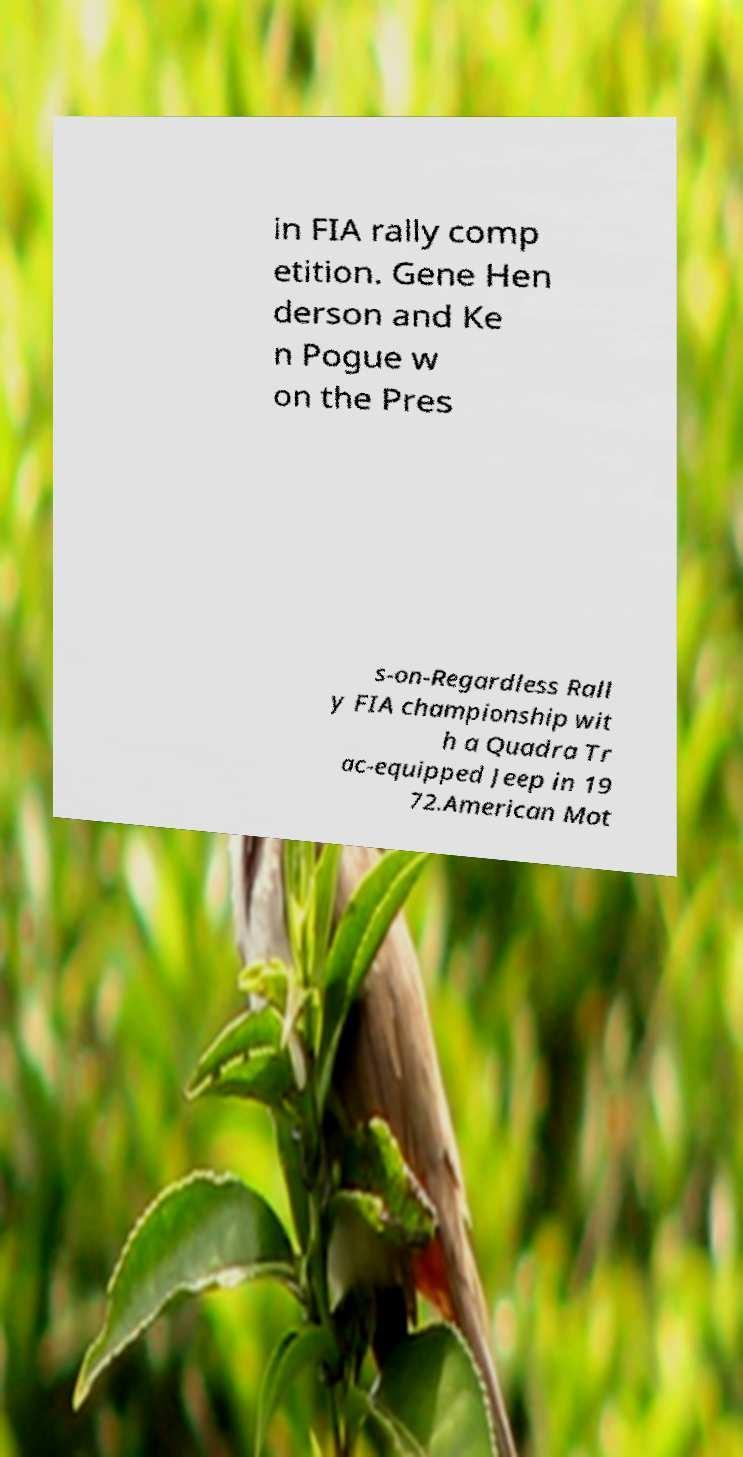Please read and relay the text visible in this image. What does it say? in FIA rally comp etition. Gene Hen derson and Ke n Pogue w on the Pres s-on-Regardless Rall y FIA championship wit h a Quadra Tr ac-equipped Jeep in 19 72.American Mot 